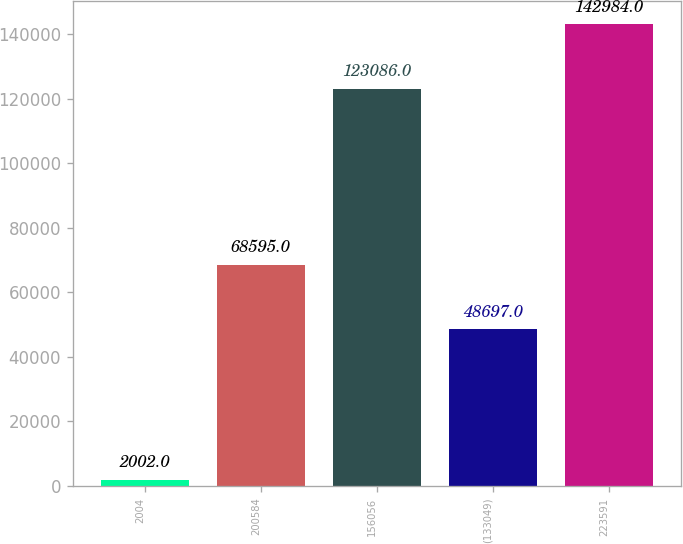Convert chart. <chart><loc_0><loc_0><loc_500><loc_500><bar_chart><fcel>2004<fcel>200584<fcel>156056<fcel>(133049)<fcel>223591<nl><fcel>2002<fcel>68595<fcel>123086<fcel>48697<fcel>142984<nl></chart> 